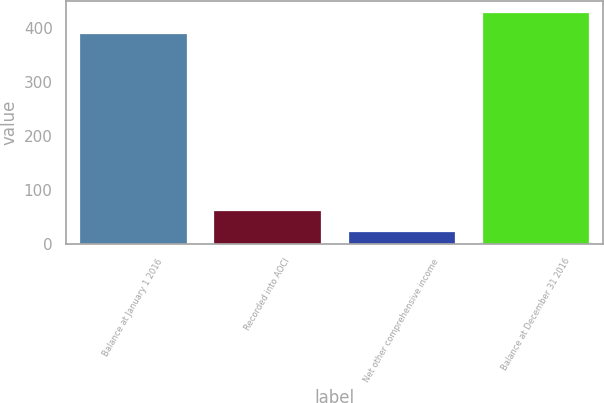Convert chart to OTSL. <chart><loc_0><loc_0><loc_500><loc_500><bar_chart><fcel>Balance at January 1 2016<fcel>Recorded into AOCI<fcel>Net other comprehensive income<fcel>Balance at December 31 2016<nl><fcel>390.4<fcel>62.74<fcel>23.7<fcel>429.44<nl></chart> 